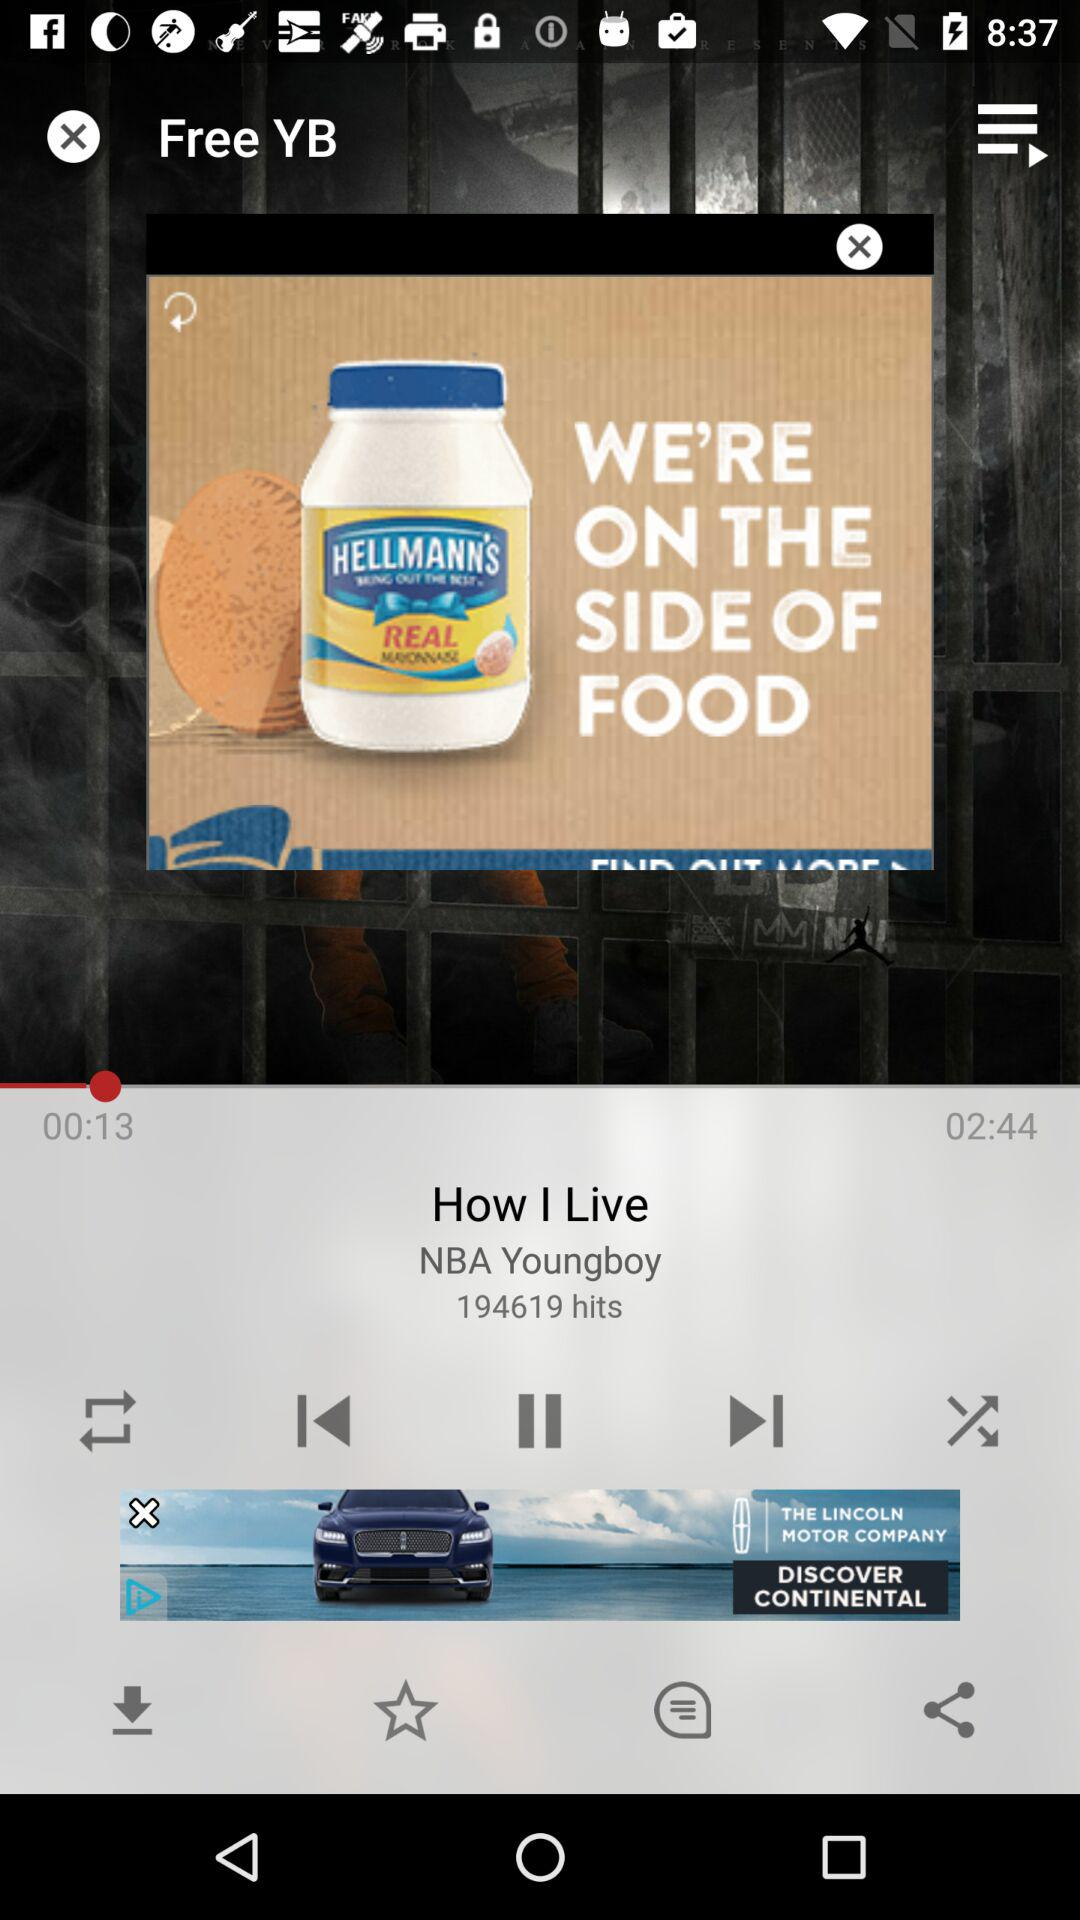How long has the song been played? The song has been played for 13 seconds. 